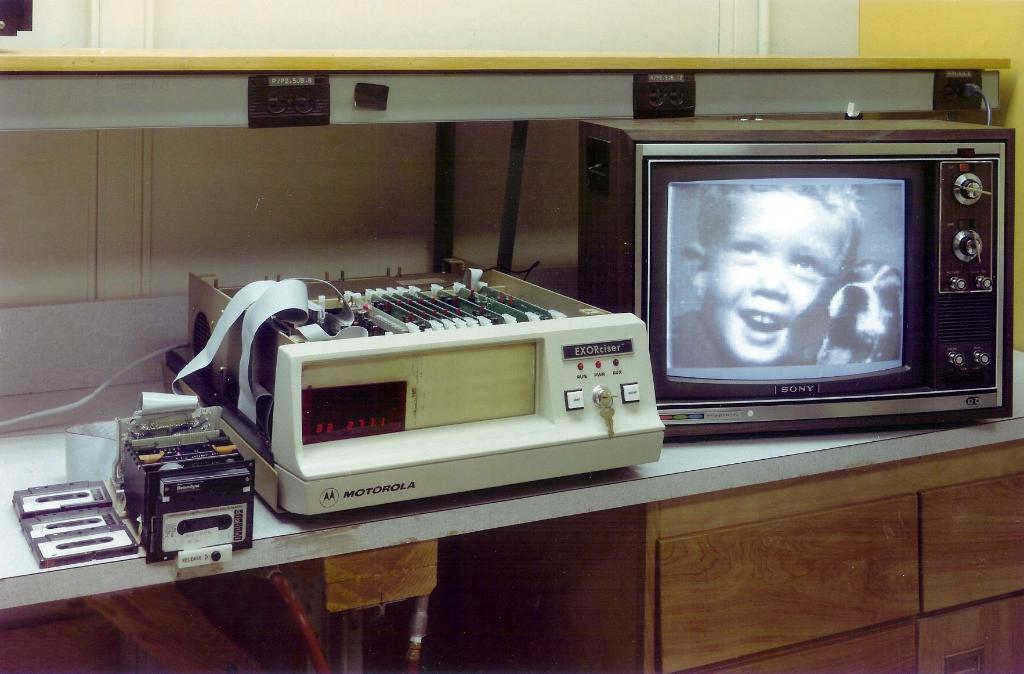What type of furniture is present in the image? There is a table with drawers in the image. What electronic device is on the table? There is a television on the table. What other items are on the table besides the television? There are other devices on the table. What type of media is visible in the image? There are cassettes in the image. What can be seen in the background of the image? There is a wall in the background. What feature is present on the wall? There are sockets on the wall. How much profit does the crate generate in the image? There is no crate present in the image, so it is not possible to determine any profit generated. 